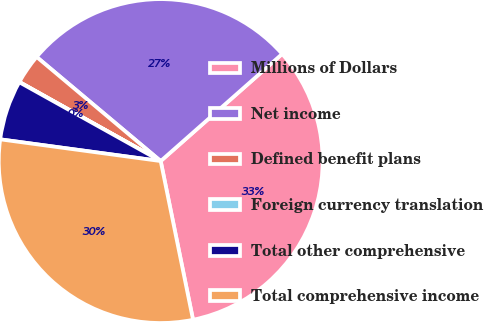Convert chart to OTSL. <chart><loc_0><loc_0><loc_500><loc_500><pie_chart><fcel>Millions of Dollars<fcel>Net income<fcel>Defined benefit plans<fcel>Foreign currency translation<fcel>Total other comprehensive<fcel>Total comprehensive income<nl><fcel>33.3%<fcel>27.38%<fcel>2.99%<fcel>0.03%<fcel>5.95%<fcel>30.34%<nl></chart> 